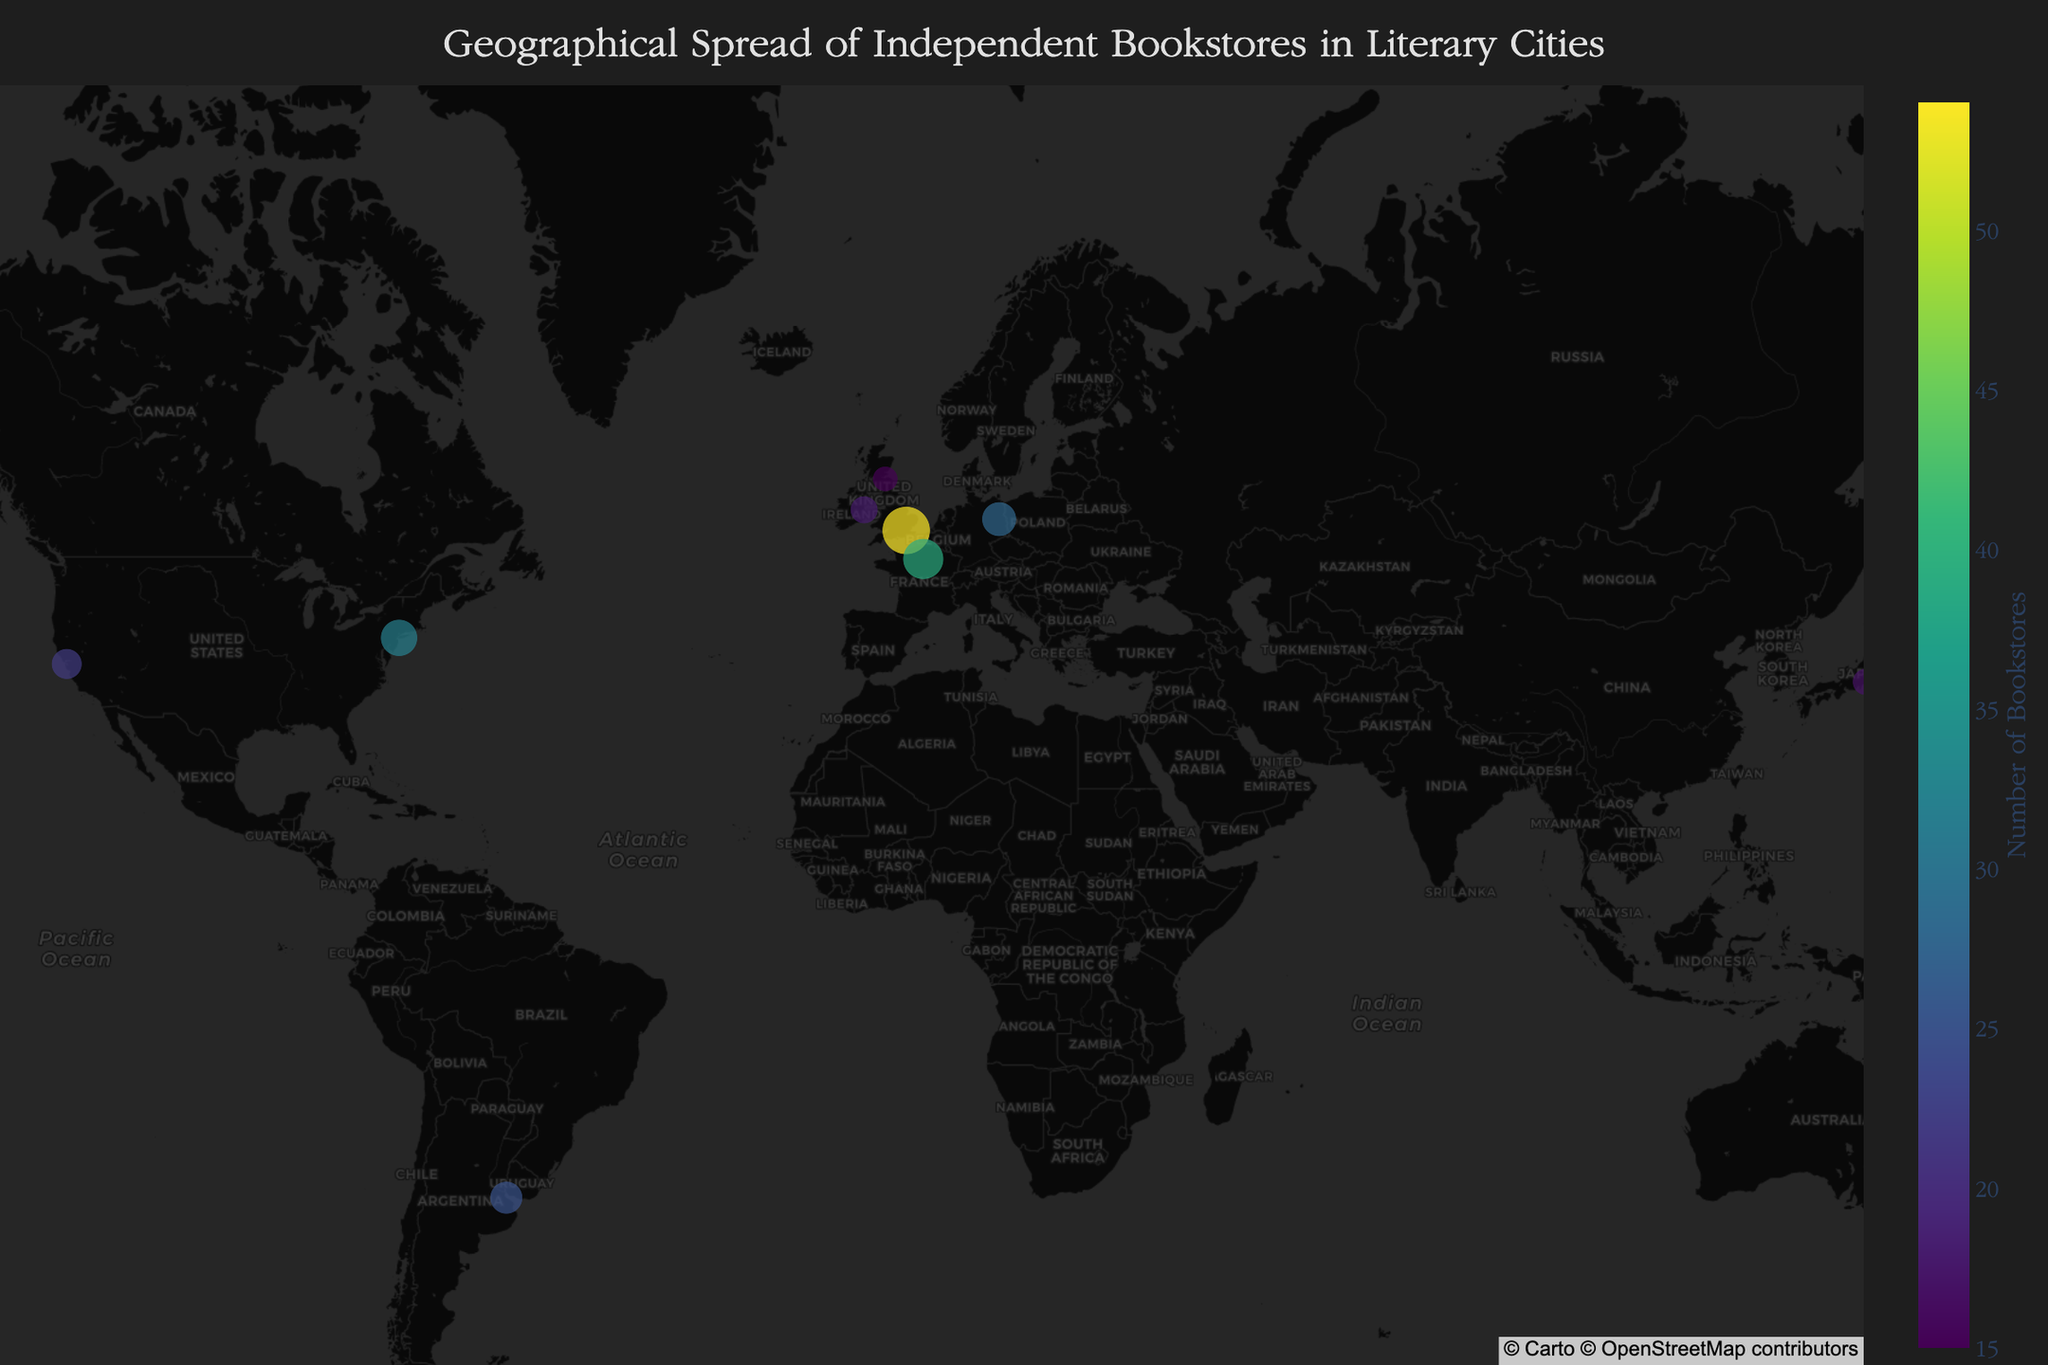what is the title of the plot? The title is usually placed at the top center of the plot and gives a summary of what the plot is about. In this case, the title of the plot provides context about the data shown.
Answer: Geographical Spread of Independent Bookstores in Literary Cities Which city has the highest number of independent bookstores? To find the city with the highest number of independent bookstores, look for the largest marker and the highest value in the color scale.
Answer: London How many independent bookstores are there in Buenos Aires? Identify the marker corresponding to Buenos Aires in the figure and refer to its associated data, which is displayed either as a size or color of the marker or in the hover information.
Answer: 25 What country is home to 'Shakespeare and Company'? Look for the hover information or the annotation near Paris to find the notable literary bookshop 'Shakespeare and Company'.
Answer: France Which city in the USA has more independent bookstores: New York or San Francisco? Compare the sizes and corresponding numbers of independent bookstores for New York and San Francisco shown in the figure.
Answer: New York How many independent bookstores are there in European cities listed on the plot? Sum the number of independent bookstores from the European cities listed on the plot (UK, France, Ireland, Germany).
Answer: 54 (London) + 39 (Paris) + 18 (Dublin) + 15 (Edinburgh) + 28 (Berlin) = 154 What is the notable literary bookshop in Melbourne? Check the hover data or the annotation associated with the marker for Melbourne.
Answer: Readings Carlton Which city has fewer independent bookstores: Dublin or Tokyo? Compare the number of bookstores for Dublin and Tokyo from their respective markers.
Answer: Tokyo Compare the number of independent bookstores in London and Tokyo. Which city has more, and by how many? Calculate the difference between the numbers of independent bookstores in London and Tokyo and determine which is greater.
Answer: London has more by 54 - 17 = 37 What is the map style used in the plot? The map style is mentioned in the layout description of the plot, giving a specific aesthetic appearance to the map.
Answer: carto-darkmatter 